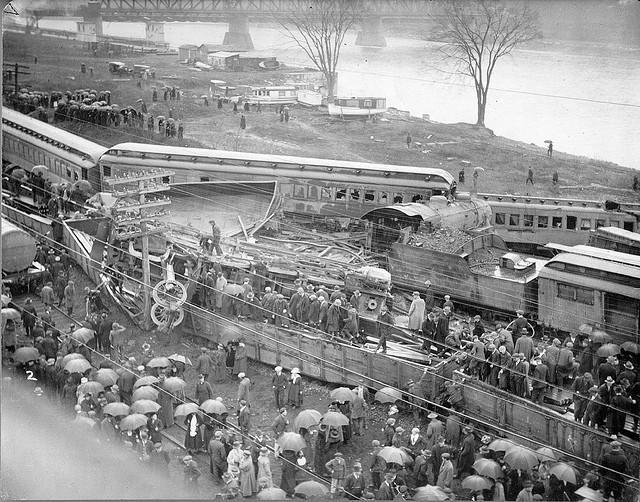Is there a train?
Write a very short answer. Yes. What color if the train?
Quick response, please. Gray. What type of scene is it?
Be succinct. Train crash. What is stretched across the water in the background?
Short answer required. Bridge. 